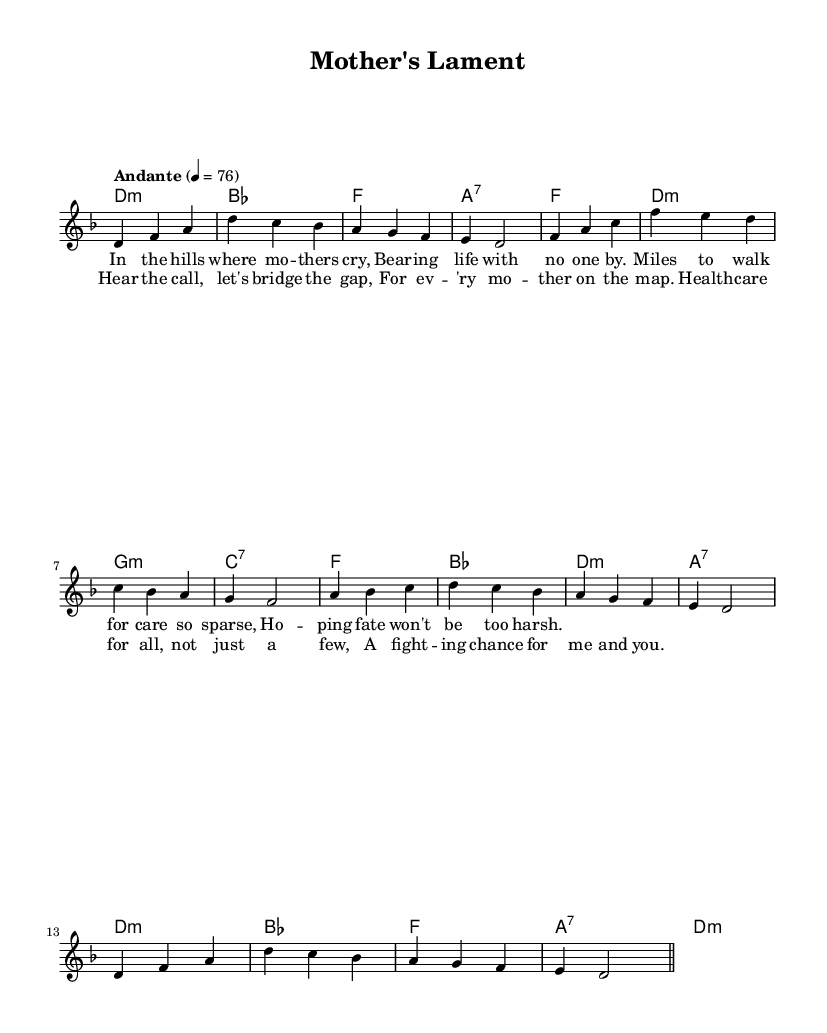What is the key signature of this music? The key signature is D minor, indicated by the presence of one flat (B flat) in the key signature section of the sheet music.
Answer: D minor What is the time signature of this music? The time signature is found at the beginning and shows that there are three beats per measure, making it a 3/4 time signature.
Answer: 3/4 What is the tempo marking of this piece? The tempo marking is indicated in Italian at the start of the piece, stating "Andante," which indicates a moderately slow tempo.
Answer: Andante How many measures are in the melody? To find the number of measures, count the divisions between the vertical lines on the score; there are 12 measures in the melody section.
Answer: 12 What is the first lyric line of the verse? The first lyric line is listed below the melody and reads, "In the hills where mo -- thers cry," making it the opening line of the verse.
Answer: In the hills where mo -- thers cry How many chords are used in the harmonies section? Counting the distinct chords in the chord mode section reveals a total of 11 unique chords utilized throughout the piece.
Answer: 11 What thematic concern does the chorus address? The chorus lyrics express a desire for increased accessibility to healthcare, focusing on equity and a collective effort to provide better care for all mothers.
Answer: Access to healthcare 